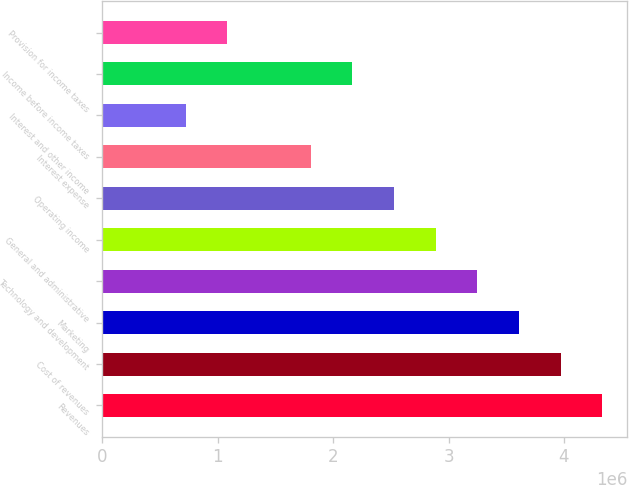Convert chart. <chart><loc_0><loc_0><loc_500><loc_500><bar_chart><fcel>Revenues<fcel>Cost of revenues<fcel>Marketing<fcel>Technology and development<fcel>General and administrative<fcel>Operating income<fcel>Interest expense<fcel>Interest and other income<fcel>Income before income taxes<fcel>Provision for income taxes<nl><fcel>4.33114e+06<fcel>3.97021e+06<fcel>3.60928e+06<fcel>3.24835e+06<fcel>2.88743e+06<fcel>2.5265e+06<fcel>1.80464e+06<fcel>721857<fcel>2.16557e+06<fcel>1.08278e+06<nl></chart> 